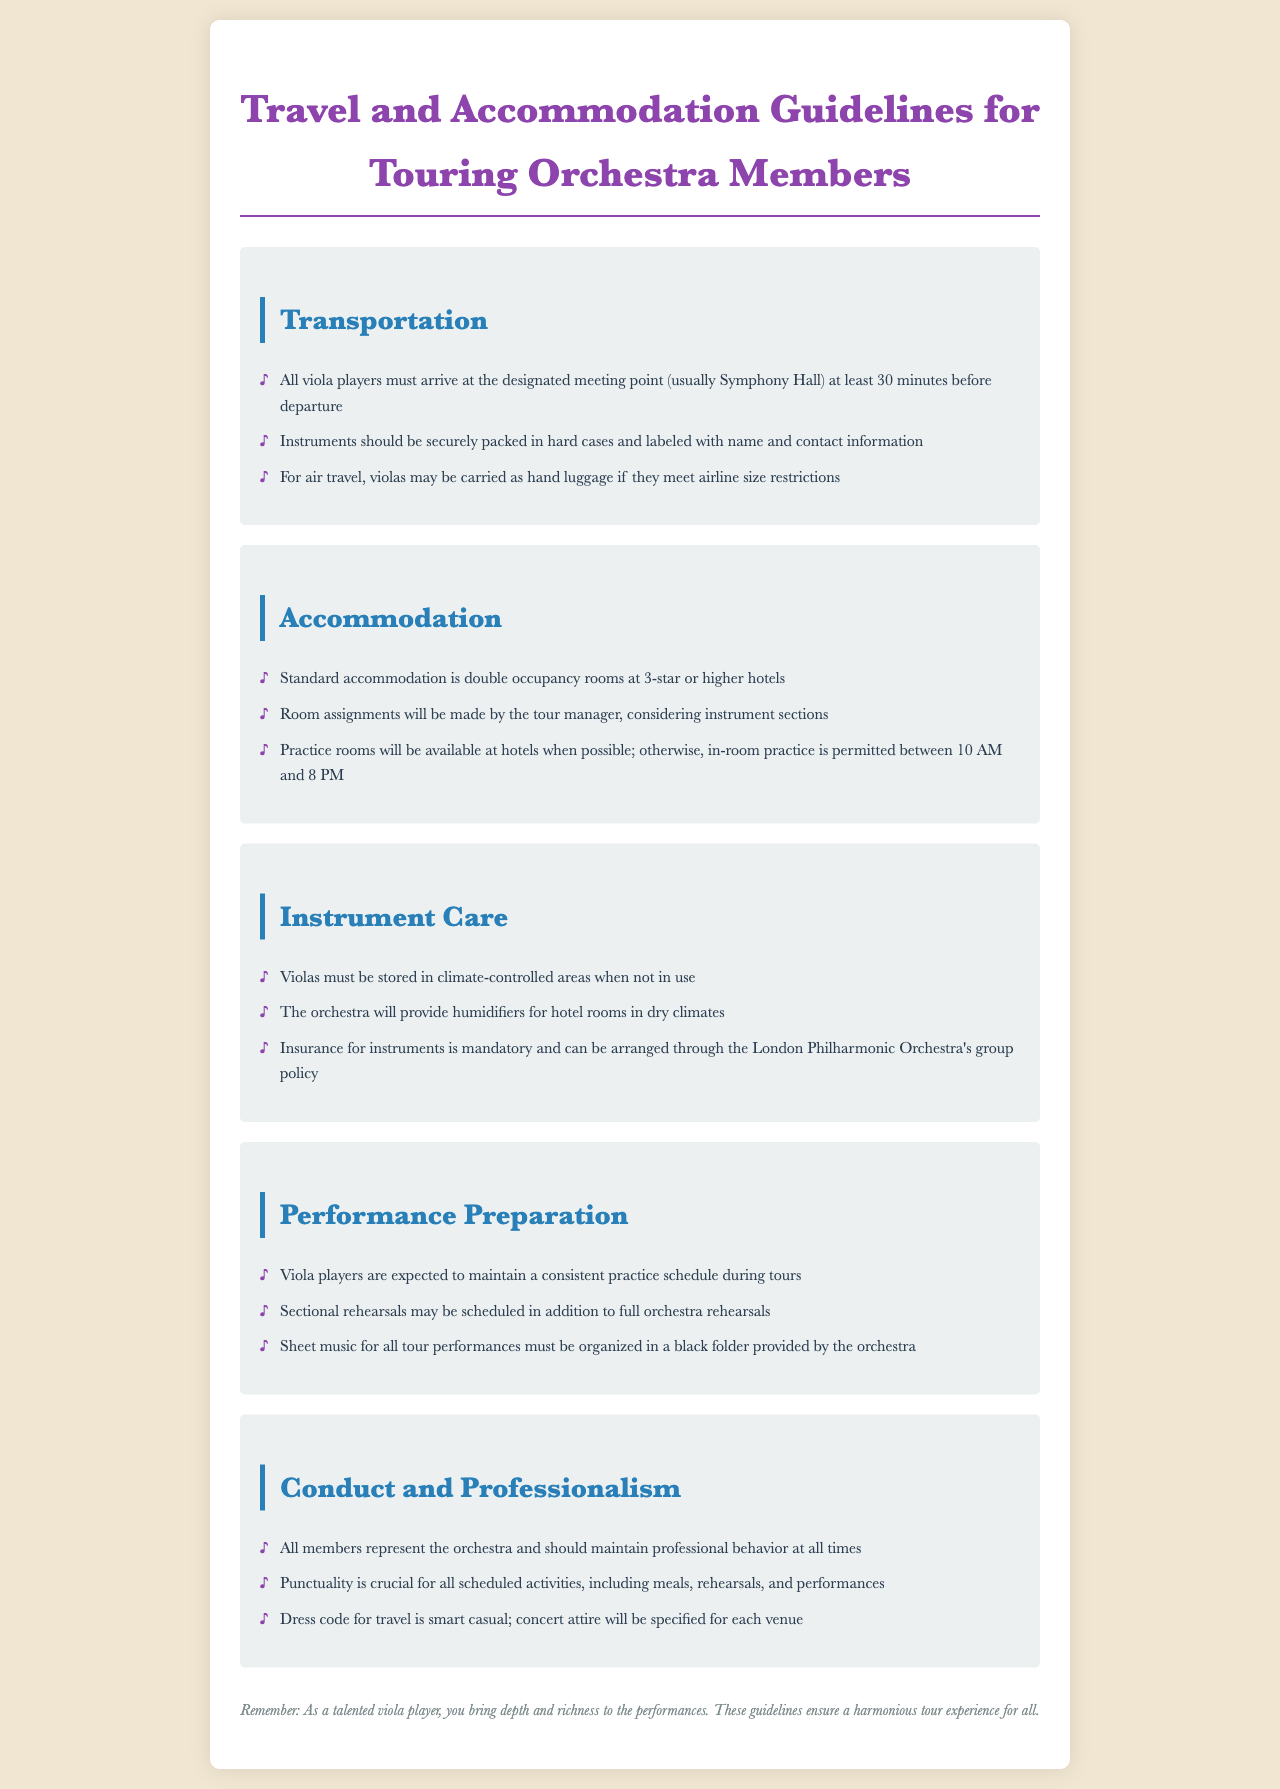what is the standard occupancy for accommodation? The document states that standard accommodation is double occupancy rooms at 3-star or higher hotels.
Answer: double occupancy rooms at 3-star or higher hotels how long before departure must members arrive at the meeting point? The policy mentions that members must arrive at least 30 minutes before departure.
Answer: 30 minutes where should violas be stored when not in use? The document specifies that violas must be stored in climate-controlled areas when not in use.
Answer: climate-controlled areas what is the dress code for travel? The dress code for travel is stated as smart casual.
Answer: smart casual who is responsible for room assignments during the tour? Room assignments during the tour will be made by the tour manager.
Answer: tour manager what is mandatory for instrument care according to the guidelines? The guidelines require that insurance for instruments is mandatory.
Answer: insurance for instruments what type of practice is permitted in hotel rooms? The document states that in-room practice is permitted between 10 AM and 8 PM.
Answer: between 10 AM and 8 PM which rooms will be provided for practicing at hotels when possible? The document mentions that practice rooms will be available at hotels when possible.
Answer: practice rooms how should instruments be packed for travel? The policy indicates that instruments should be securely packed in hard cases and labeled with name and contact information.
Answer: securely packed in hard cases 